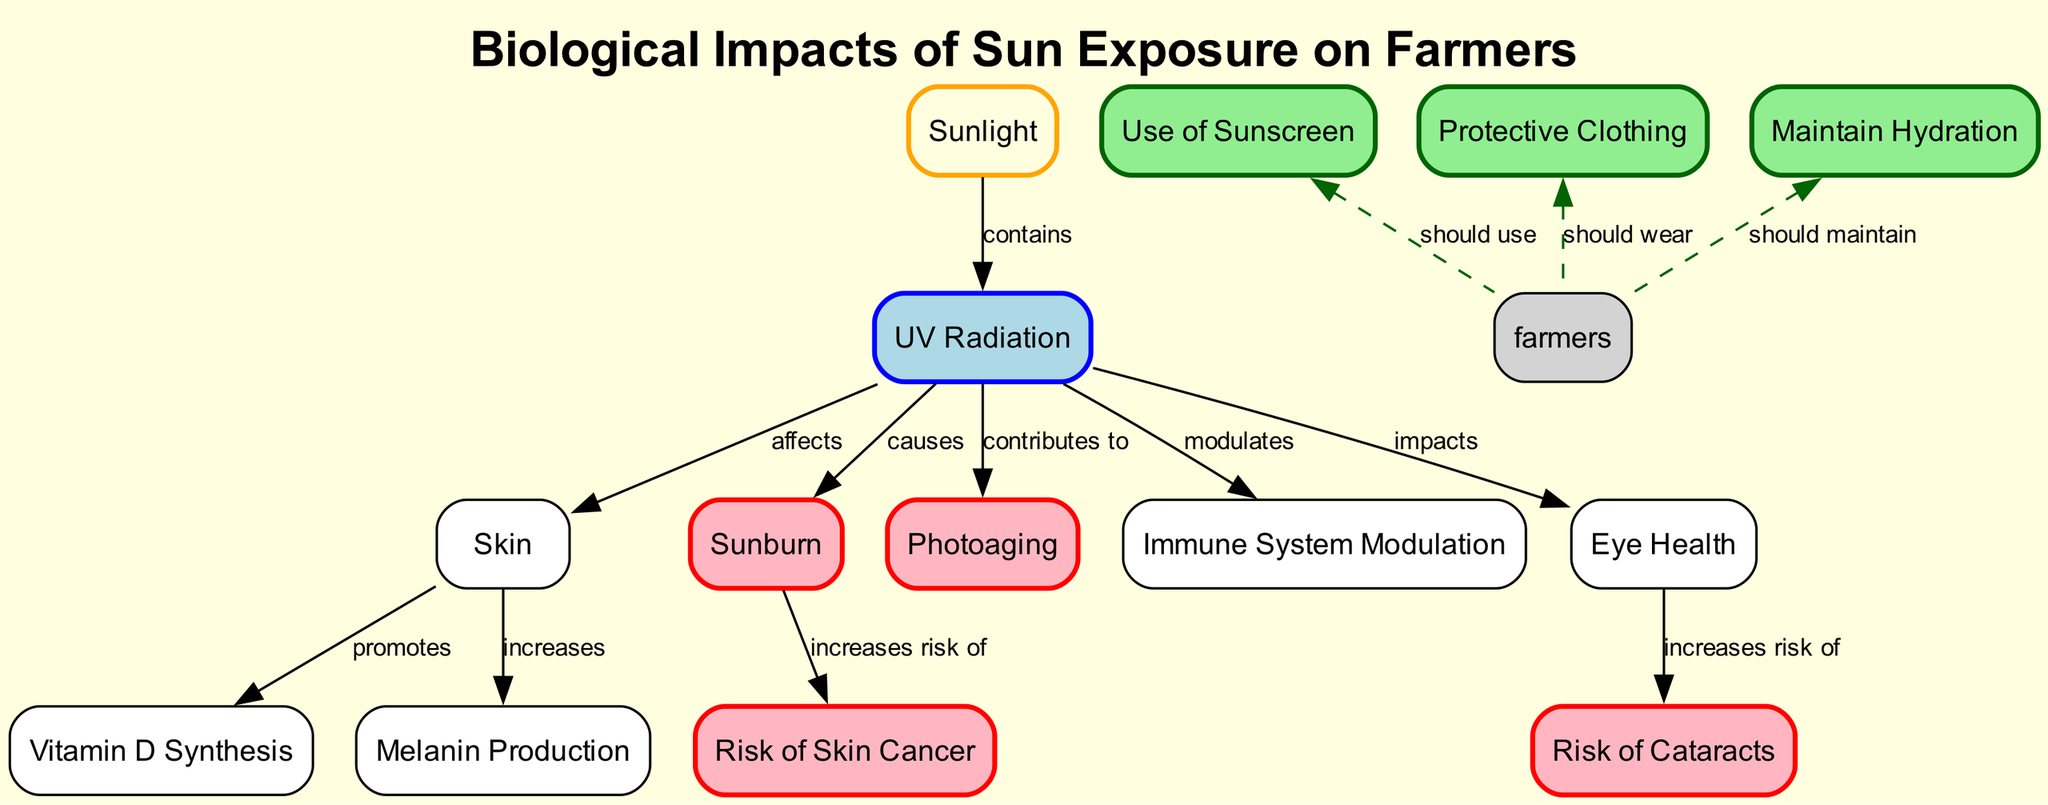What nodes are directly affected by UV Radiation? The diagram shows that UV Radiation affects the Skin, contributes to Photoaging, and modulates the Immune System. Therefore, the nodes directly affected by UV Radiation are Skin, Photoaging, and Immune System.
Answer: Skin, Photoaging, Immune System How does sunlight relate to UV radiation? The diagram indicates that Sunlight contains UV Radiation. This indicates a direct relationship where sunlight is a source of UV radiation.
Answer: Contains What is the risk that increases due to Sunburn? According to the diagram, Sunburn increases the risk of Skin Cancer. The relationship shows that one condition leads to a heightened risk of another condition.
Answer: Skin Cancer What should farmers maintain according to the diagram? The diagram suggests that Farmers should maintain Hydration. It provides a clear recommendation for farmers in relation to sun exposure and its effects on health.
Answer: Hydration What increases in the skin due to UV Radiation? The diagram illustrates that UV Radiation affects the skin and promotes the increase of Melanin. This relationship highlights how the skin responds to UV exposure.
Answer: Melanin What is the relationship between Eye Health and Cataracts? The diagram states that Eye Health increases the risk of Cataracts. This shows a causative connection where the condition of eye health contributes to the likelihood of developing cataracts.
Answer: Increases risk of What should farmers use to protect themselves? The diagram indicates that Farmers should use Sunscreen. This is a preventative measure suggested in response to the effects of sun exposure.
Answer: Sunscreen How many nodes are in the diagram? The diagram contains a total of 14 nodes. This total includes all aspects and health concerns represented in relation to sun exposure for farmers.
Answer: 14 